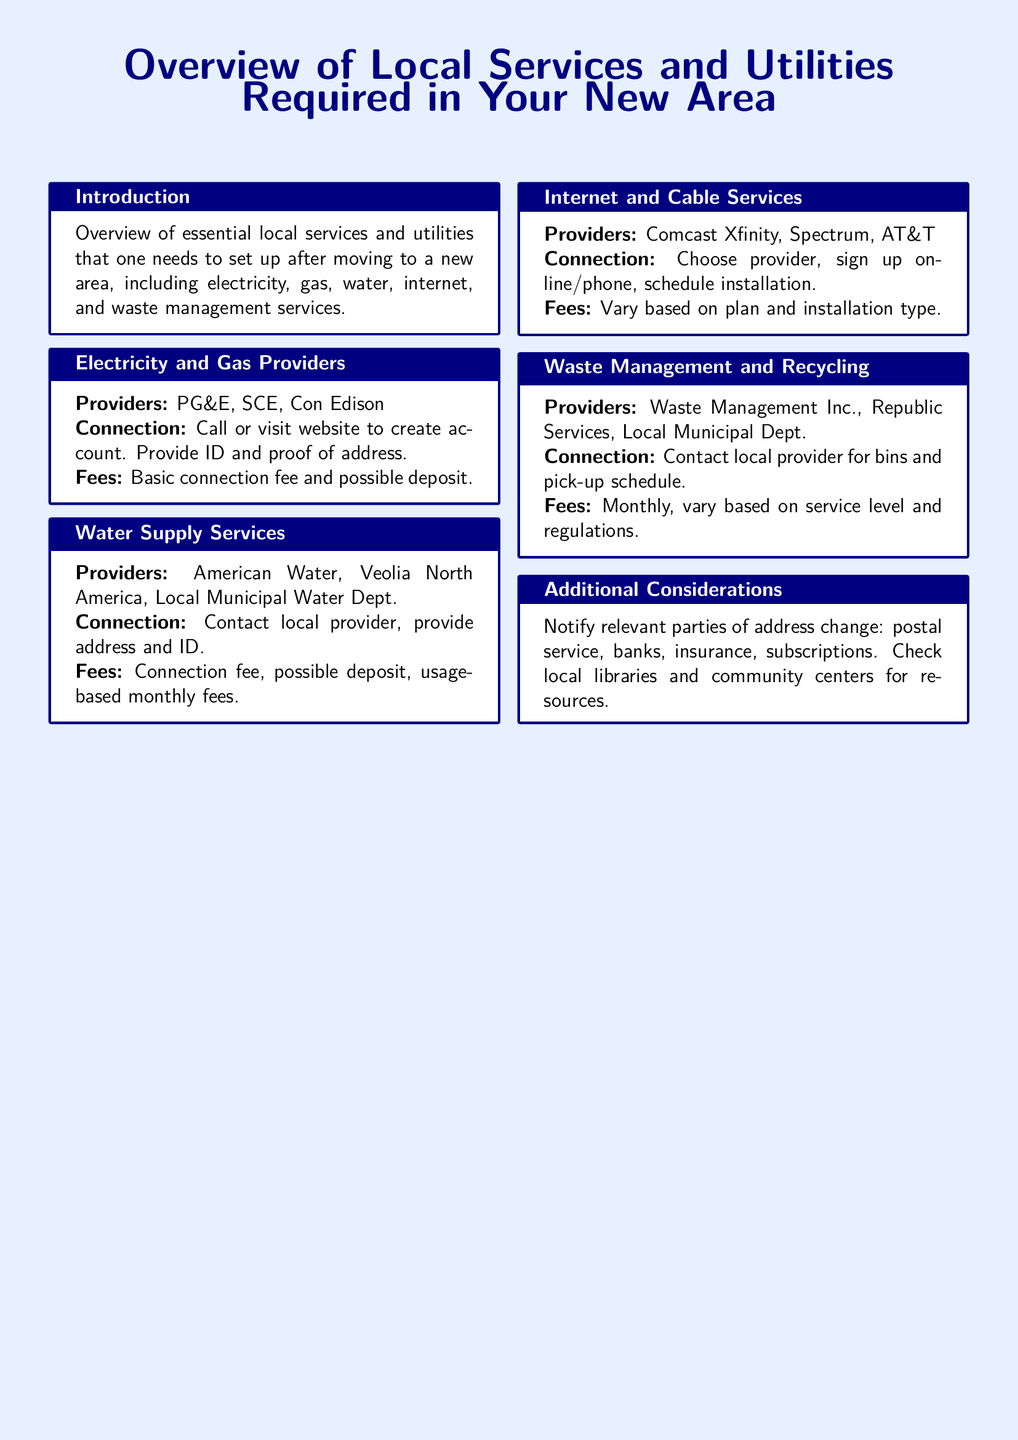What providers are listed for electricity? The document mentions PG&E, SCE, and Con Edison as electricity providers.
Answer: PG&E, SCE, Con Edison What do you need to provide to set up electricity and gas services? You need to provide ID and proof of address for setting up electricity and gas services.
Answer: ID and proof of address What are the potential fees for water supply services? The document lists connection fee, possible deposit, and usage-based monthly fees as potential costs for water supply services.
Answer: Connection fee, possible deposit, usage-based monthly fees Which internet provider offers installation scheduling? Comcast Xfinity, Spectrum, and AT&T are mentioned as internet providers that offer installation scheduling.
Answer: Comcast Xfinity, Spectrum, AT&T What should you notify after changing your address? The document states that you should notify the postal service, banks, insurance, and subscriptions about your address change.
Answer: Postal service, banks, insurance, subscriptions What is the name of a waste management provider? Waste Management Inc. is one of the waste management providers mentioned in the document.
Answer: Waste Management Inc What is the first step to connect to water supply services? You must contact the local provider to connect to water supply services.
Answer: Contact local provider How varies the fee for internet services? The document indicates that fees vary based on plan and installation type for internet services.
Answer: Vary based on plan and installation type What is covered in the introduction section? The introduction provides an overview of essential local services and utilities needed after moving to a new area.
Answer: Overview of essential local services and utilities 